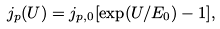Convert formula to latex. <formula><loc_0><loc_0><loc_500><loc_500>j _ { p } ( U ) = j _ { p , 0 } [ \exp ( U / E _ { 0 } ) - 1 ] ,</formula> 